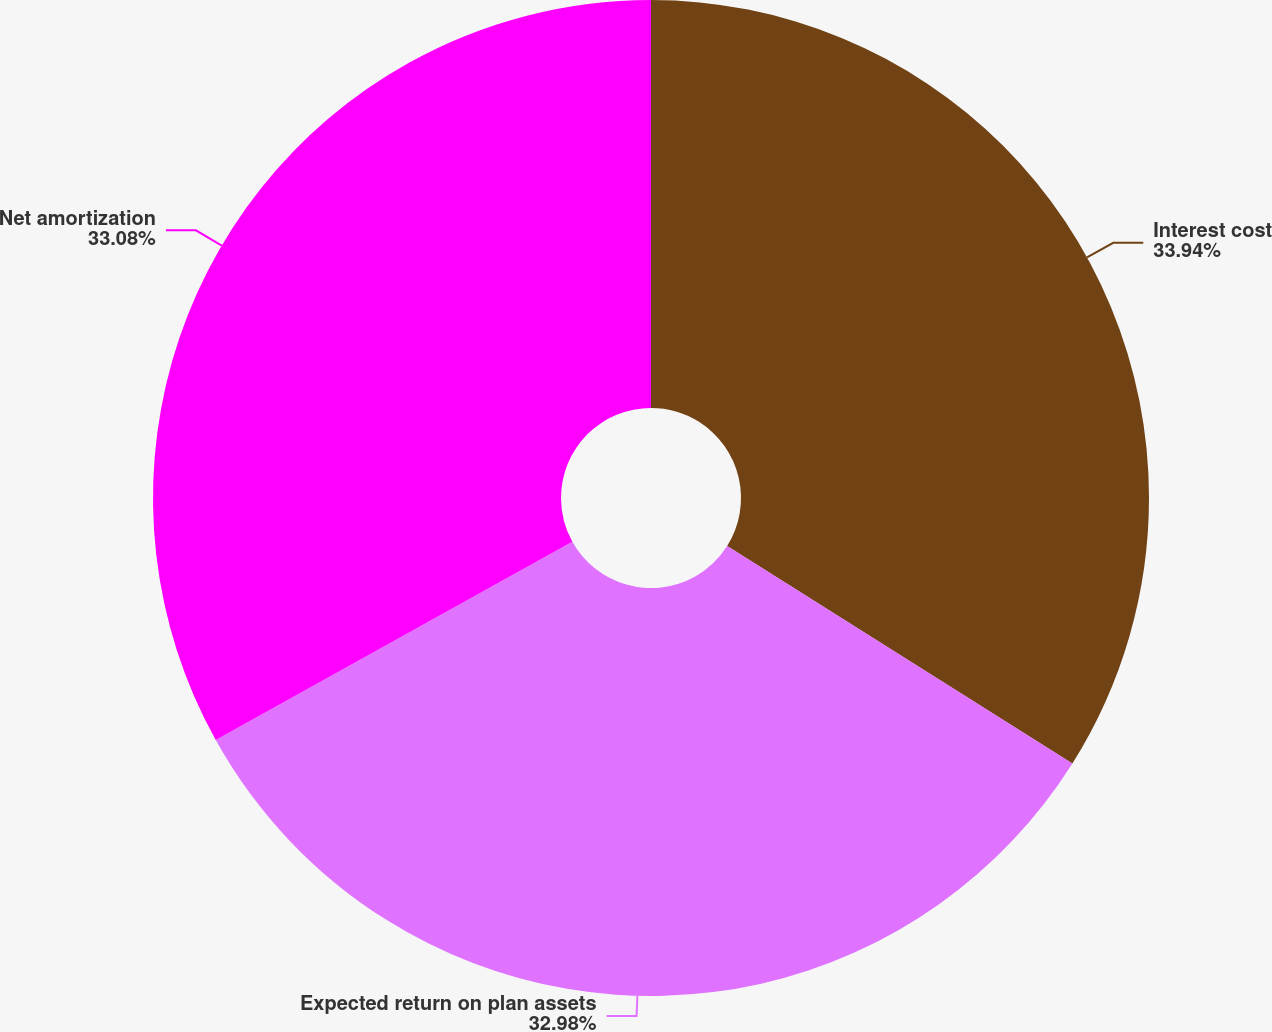Convert chart. <chart><loc_0><loc_0><loc_500><loc_500><pie_chart><fcel>Interest cost<fcel>Expected return on plan assets<fcel>Net amortization<nl><fcel>33.95%<fcel>32.98%<fcel>33.08%<nl></chart> 